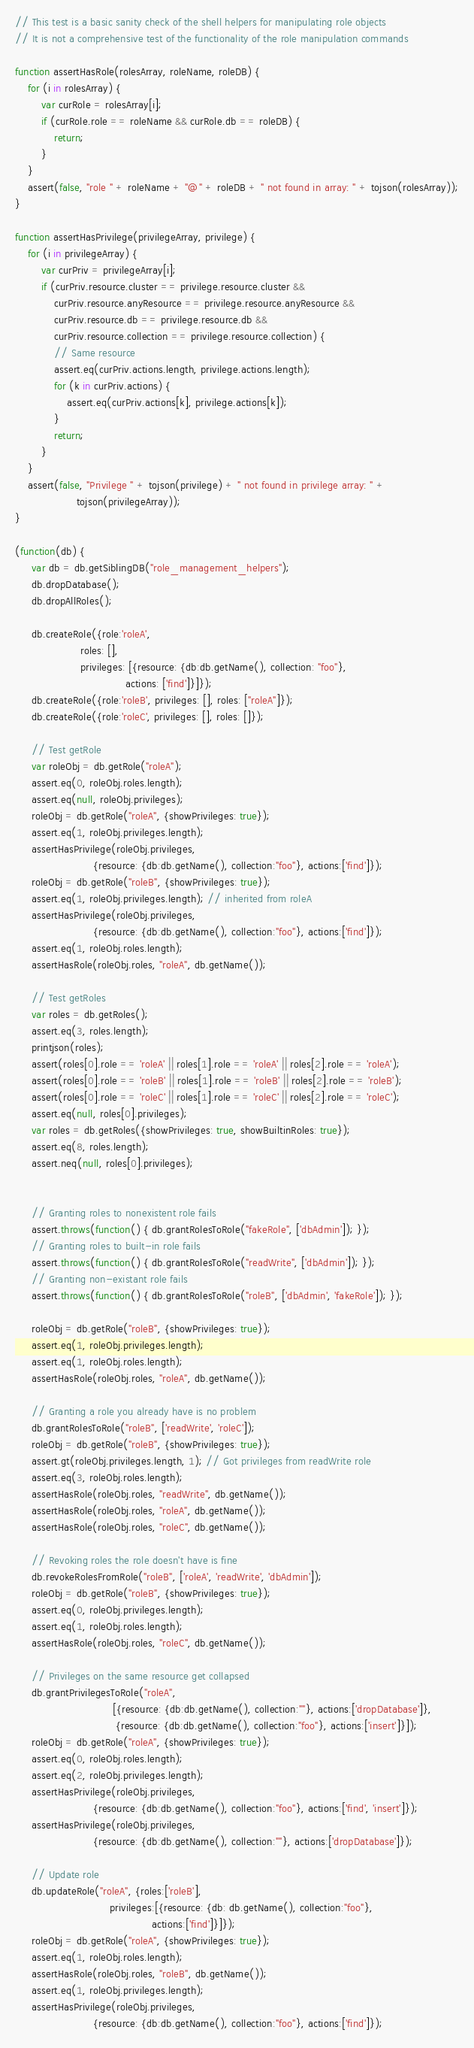Convert code to text. <code><loc_0><loc_0><loc_500><loc_500><_JavaScript_>// This test is a basic sanity check of the shell helpers for manipulating role objects
// It is not a comprehensive test of the functionality of the role manipulation commands

function assertHasRole(rolesArray, roleName, roleDB) {
    for (i in rolesArray) {
        var curRole = rolesArray[i];
        if (curRole.role == roleName && curRole.db == roleDB) {
            return;
        }
    }
    assert(false, "role " + roleName + "@" + roleDB + " not found in array: " + tojson(rolesArray));
}

function assertHasPrivilege(privilegeArray, privilege) {
    for (i in privilegeArray) {
        var curPriv = privilegeArray[i];
        if (curPriv.resource.cluster == privilege.resource.cluster &&
            curPriv.resource.anyResource == privilege.resource.anyResource &&
            curPriv.resource.db == privilege.resource.db &&
            curPriv.resource.collection == privilege.resource.collection) {
            // Same resource
            assert.eq(curPriv.actions.length, privilege.actions.length);
            for (k in curPriv.actions) {
                assert.eq(curPriv.actions[k], privilege.actions[k]);
            }
            return;
        }
    }
    assert(false, "Privilege " + tojson(privilege) + " not found in privilege array: " +
                   tojson(privilegeArray));
}

(function(db) {
     var db = db.getSiblingDB("role_management_helpers");
     db.dropDatabase();
     db.dropAllRoles();

     db.createRole({role:'roleA',
                    roles: [],
                    privileges: [{resource: {db:db.getName(), collection: "foo"},
                                  actions: ['find']}]});
     db.createRole({role:'roleB', privileges: [], roles: ["roleA"]});
     db.createRole({role:'roleC', privileges: [], roles: []});

     // Test getRole
     var roleObj = db.getRole("roleA");
     assert.eq(0, roleObj.roles.length);
     assert.eq(null, roleObj.privileges);
     roleObj = db.getRole("roleA", {showPrivileges: true});
     assert.eq(1, roleObj.privileges.length);
     assertHasPrivilege(roleObj.privileges,
                        {resource: {db:db.getName(), collection:"foo"}, actions:['find']});
     roleObj = db.getRole("roleB", {showPrivileges: true});
     assert.eq(1, roleObj.privileges.length); // inherited from roleA
     assertHasPrivilege(roleObj.privileges,
                        {resource: {db:db.getName(), collection:"foo"}, actions:['find']});
     assert.eq(1, roleObj.roles.length);
     assertHasRole(roleObj.roles, "roleA", db.getName());

     // Test getRoles
     var roles = db.getRoles();
     assert.eq(3, roles.length);
     printjson(roles);
     assert(roles[0].role == 'roleA' || roles[1].role == 'roleA' || roles[2].role == 'roleA');
     assert(roles[0].role == 'roleB' || roles[1].role == 'roleB' || roles[2].role == 'roleB');
     assert(roles[0].role == 'roleC' || roles[1].role == 'roleC' || roles[2].role == 'roleC');
     assert.eq(null, roles[0].privileges);
     var roles = db.getRoles({showPrivileges: true, showBuiltinRoles: true});
     assert.eq(8, roles.length);
     assert.neq(null, roles[0].privileges);


     // Granting roles to nonexistent role fails
     assert.throws(function() { db.grantRolesToRole("fakeRole", ['dbAdmin']); });
     // Granting roles to built-in role fails
     assert.throws(function() { db.grantRolesToRole("readWrite", ['dbAdmin']); });
     // Granting non-existant role fails
     assert.throws(function() { db.grantRolesToRole("roleB", ['dbAdmin', 'fakeRole']); });

     roleObj = db.getRole("roleB", {showPrivileges: true});
     assert.eq(1, roleObj.privileges.length);
     assert.eq(1, roleObj.roles.length);
     assertHasRole(roleObj.roles, "roleA", db.getName());

     // Granting a role you already have is no problem
     db.grantRolesToRole("roleB", ['readWrite', 'roleC']);
     roleObj = db.getRole("roleB", {showPrivileges: true});
     assert.gt(roleObj.privileges.length, 1); // Got privileges from readWrite role
     assert.eq(3, roleObj.roles.length);
     assertHasRole(roleObj.roles, "readWrite", db.getName());
     assertHasRole(roleObj.roles, "roleA", db.getName());
     assertHasRole(roleObj.roles, "roleC", db.getName());

     // Revoking roles the role doesn't have is fine
     db.revokeRolesFromRole("roleB", ['roleA', 'readWrite', 'dbAdmin']);
     roleObj = db.getRole("roleB", {showPrivileges: true});
     assert.eq(0, roleObj.privileges.length);
     assert.eq(1, roleObj.roles.length);
     assertHasRole(roleObj.roles, "roleC", db.getName());

     // Privileges on the same resource get collapsed
     db.grantPrivilegesToRole("roleA",
                              [{resource: {db:db.getName(), collection:""}, actions:['dropDatabase']},
                               {resource: {db:db.getName(), collection:"foo"}, actions:['insert']}]);
     roleObj = db.getRole("roleA", {showPrivileges: true});
     assert.eq(0, roleObj.roles.length);
     assert.eq(2, roleObj.privileges.length);
     assertHasPrivilege(roleObj.privileges,
                        {resource: {db:db.getName(), collection:"foo"}, actions:['find', 'insert']});
     assertHasPrivilege(roleObj.privileges,
                        {resource: {db:db.getName(), collection:""}, actions:['dropDatabase']});

     // Update role
     db.updateRole("roleA", {roles:['roleB'],
                             privileges:[{resource: {db: db.getName(), collection:"foo"},
                                          actions:['find']}]});
     roleObj = db.getRole("roleA", {showPrivileges: true});
     assert.eq(1, roleObj.roles.length);
     assertHasRole(roleObj.roles, "roleB", db.getName());
     assert.eq(1, roleObj.privileges.length);
     assertHasPrivilege(roleObj.privileges,
                        {resource: {db:db.getName(), collection:"foo"}, actions:['find']});
</code> 